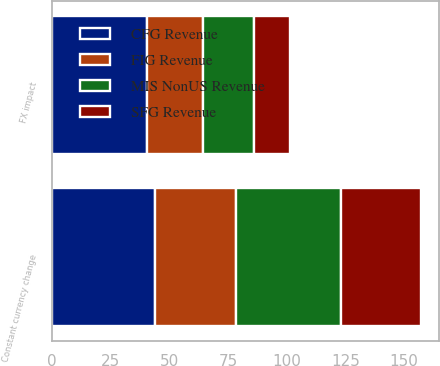<chart> <loc_0><loc_0><loc_500><loc_500><stacked_bar_chart><ecel><fcel>FX impact<fcel>Constant currency change<nl><fcel>CFG Revenue<fcel>40.7<fcel>44.1<nl><fcel>MIS NonUS Revenue<fcel>22<fcel>44.6<nl><fcel>FIG Revenue<fcel>23.5<fcel>34.4<nl><fcel>SFG Revenue<fcel>15.1<fcel>34.2<nl></chart> 